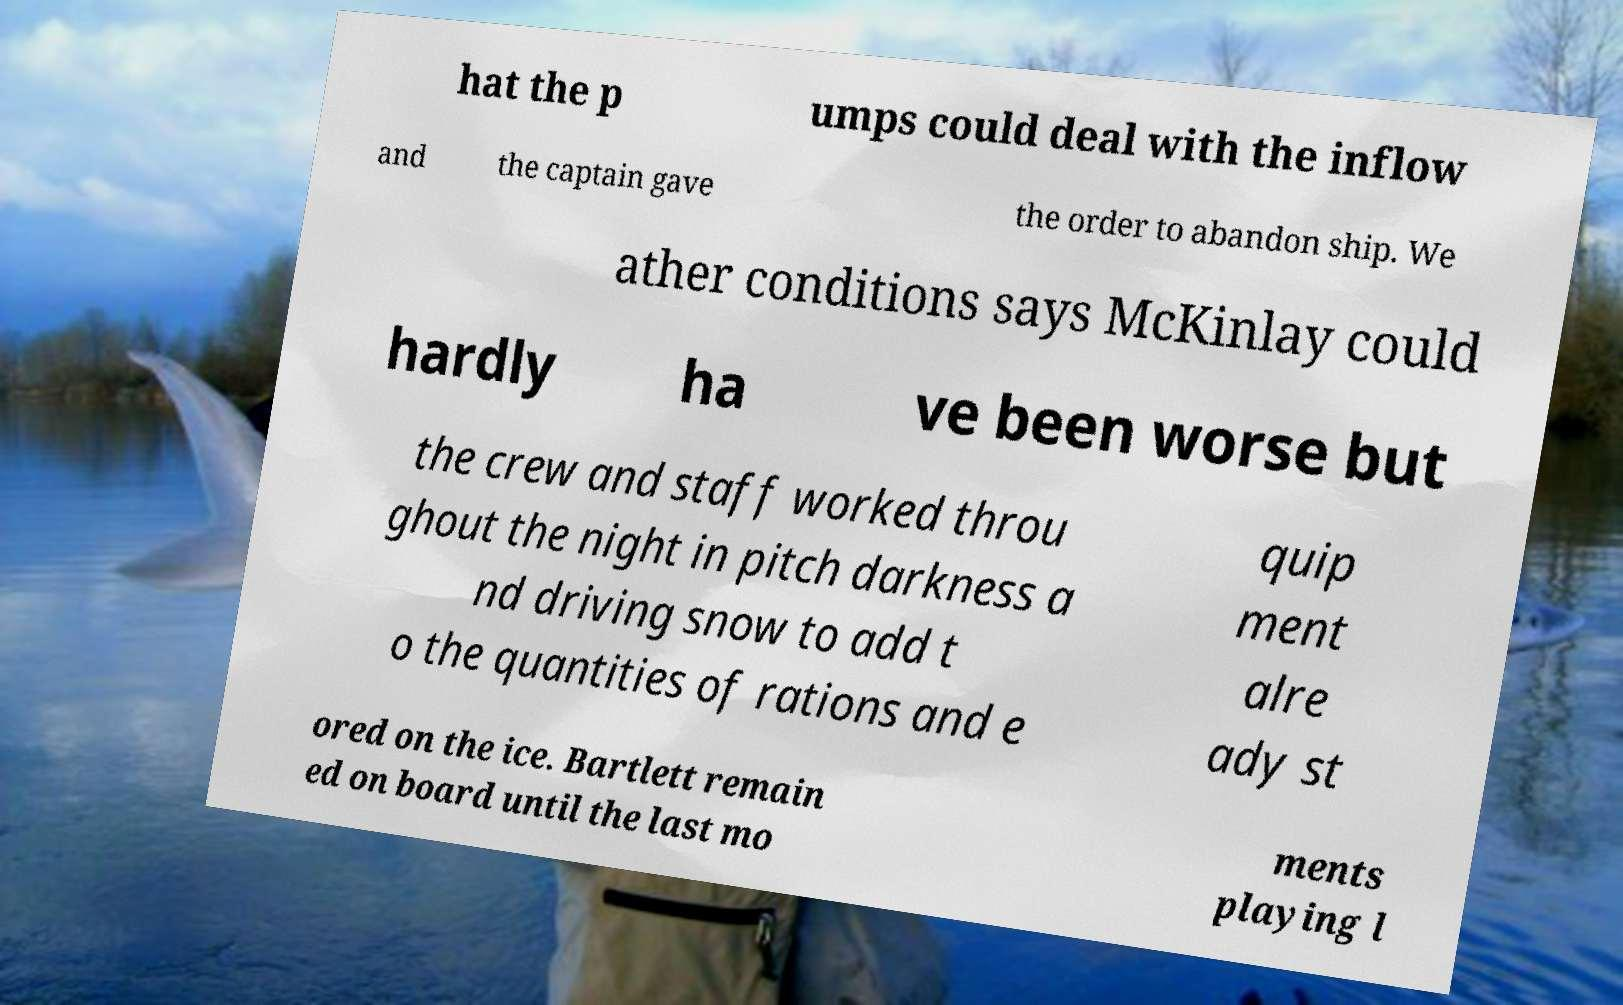For documentation purposes, I need the text within this image transcribed. Could you provide that? hat the p umps could deal with the inflow and the captain gave the order to abandon ship. We ather conditions says McKinlay could hardly ha ve been worse but the crew and staff worked throu ghout the night in pitch darkness a nd driving snow to add t o the quantities of rations and e quip ment alre ady st ored on the ice. Bartlett remain ed on board until the last mo ments playing l 